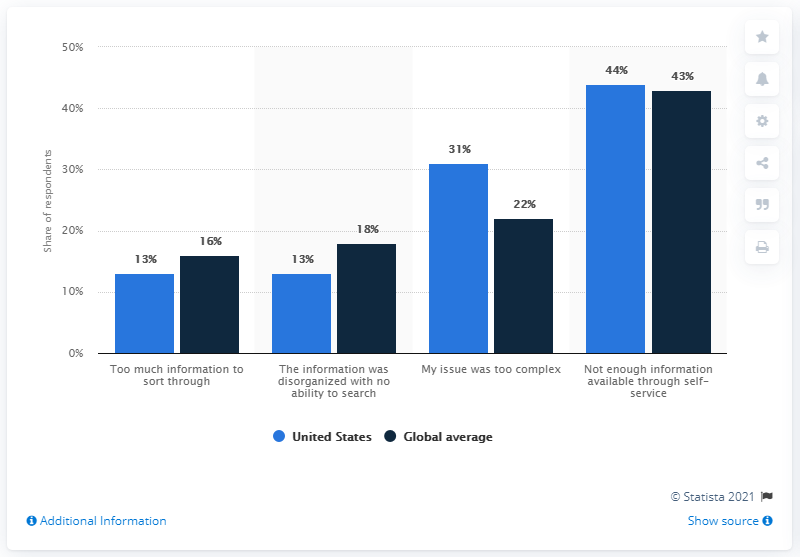Point out several critical features in this image. Thirteen percent of respondents from the United States identified disorganized information as their primary concern with self-service. 